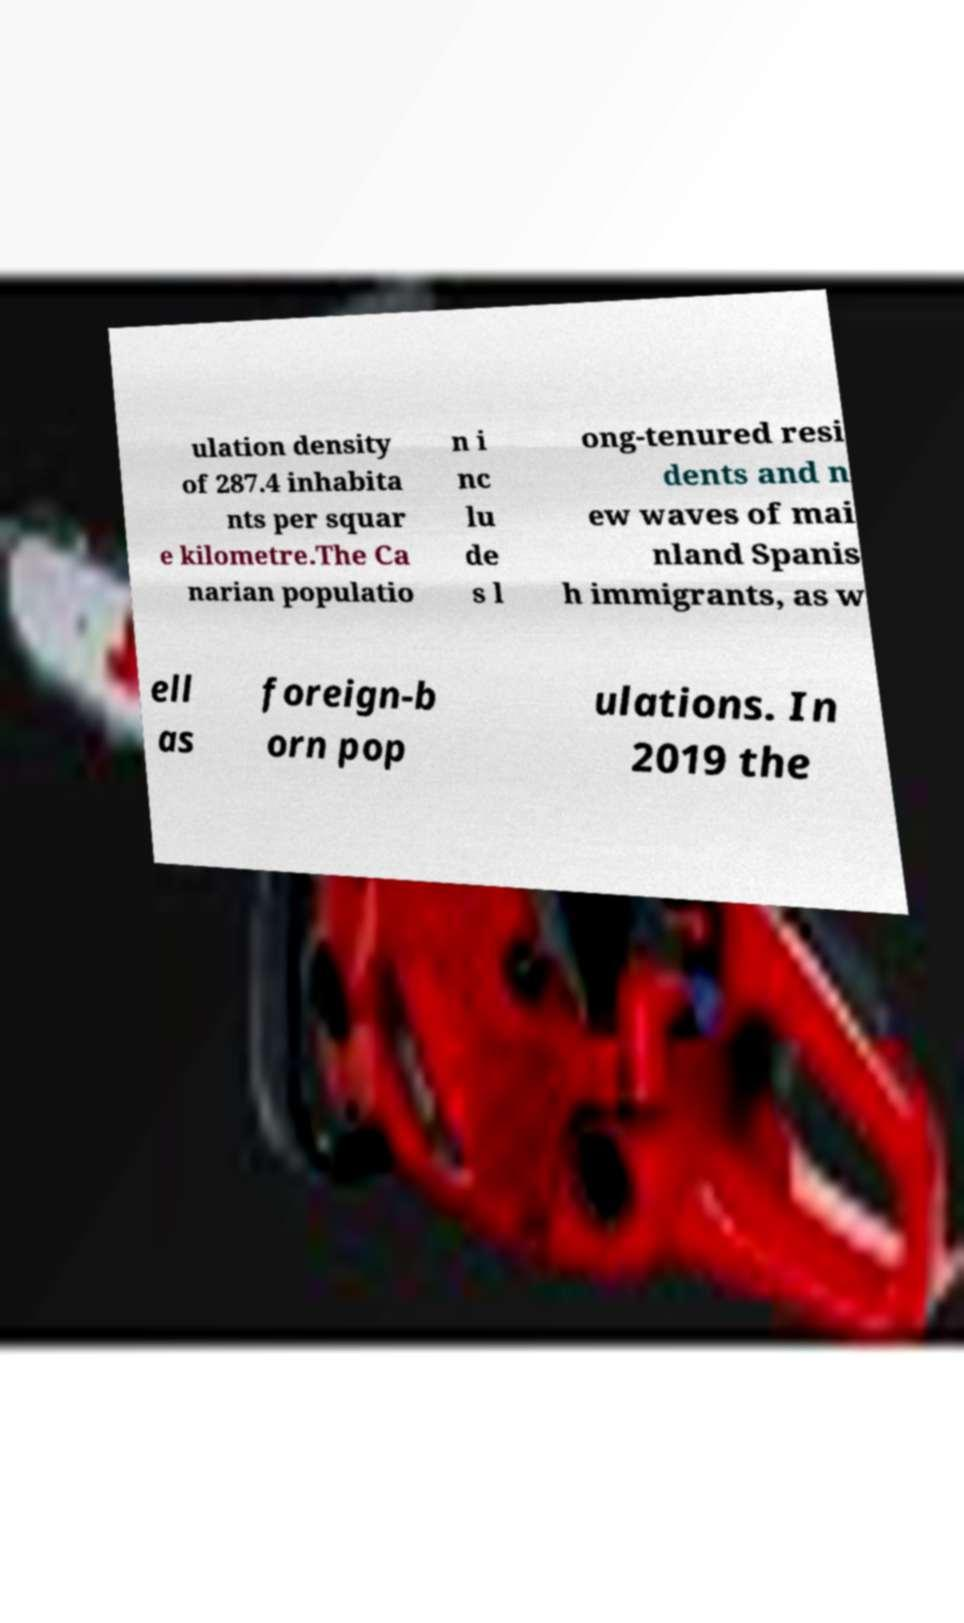Please read and relay the text visible in this image. What does it say? ulation density of 287.4 inhabita nts per squar e kilometre.The Ca narian populatio n i nc lu de s l ong-tenured resi dents and n ew waves of mai nland Spanis h immigrants, as w ell as foreign-b orn pop ulations. In 2019 the 